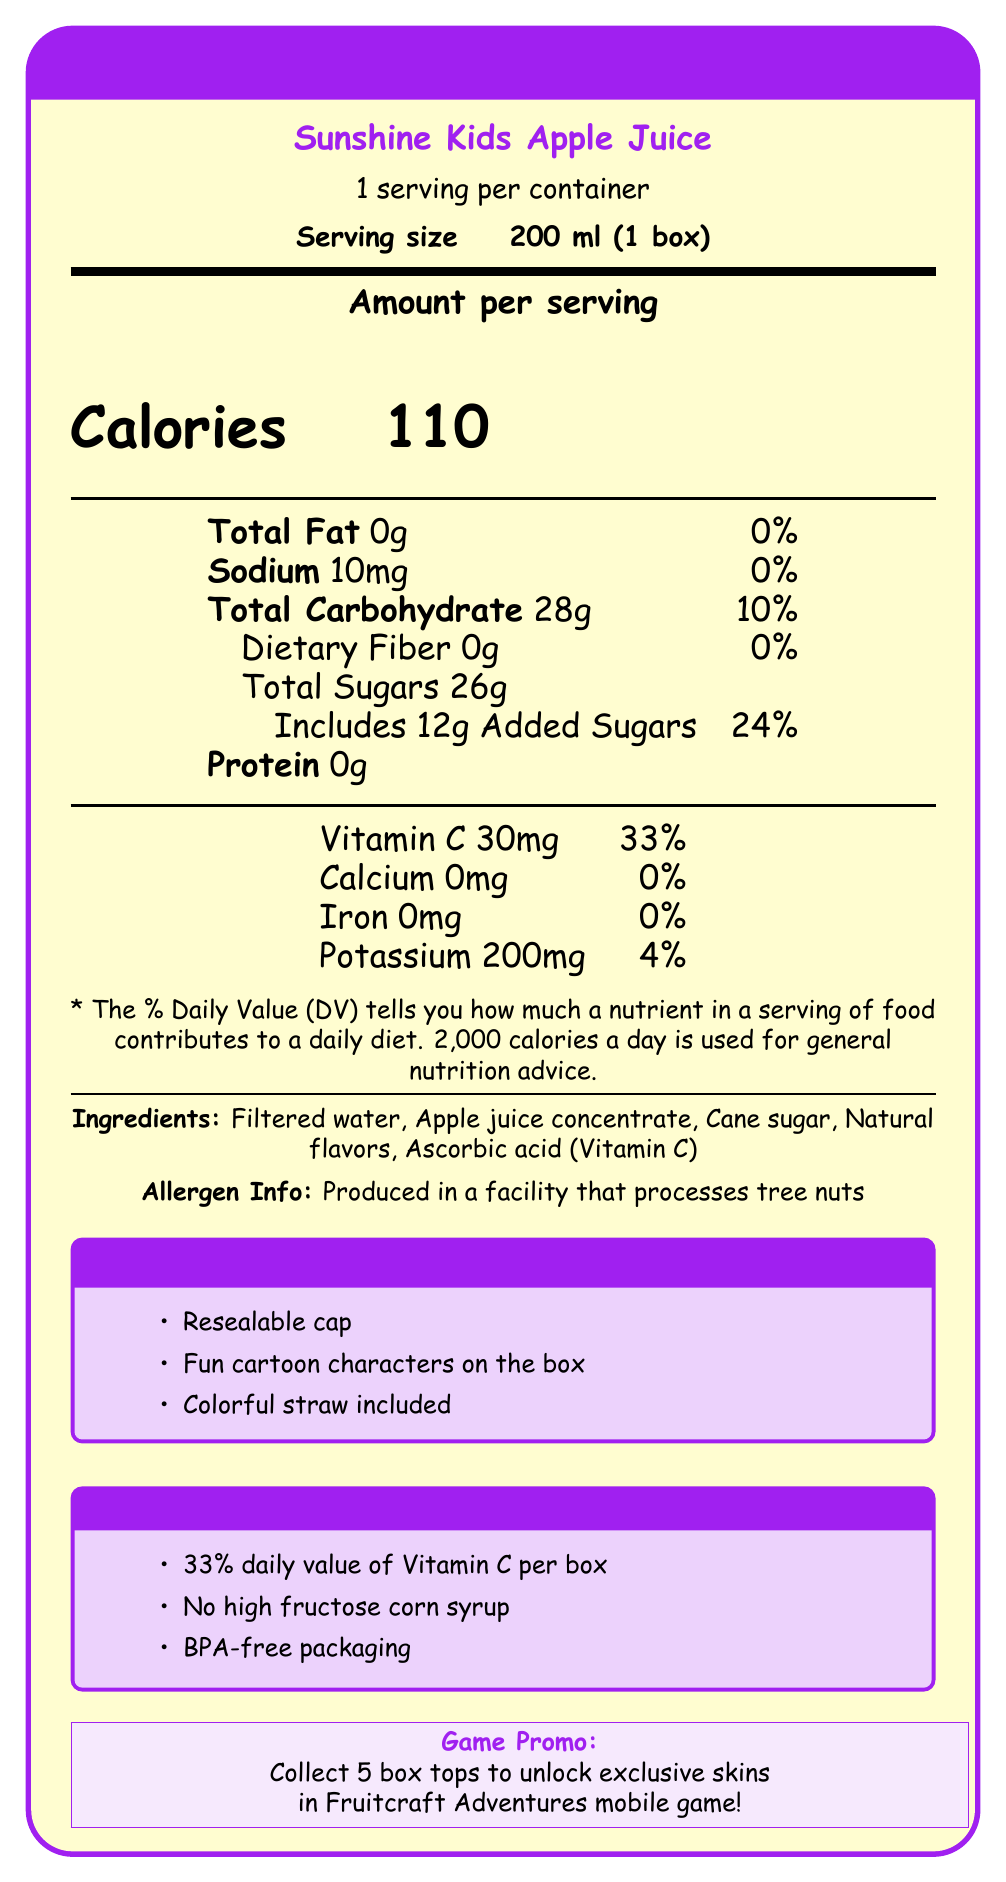How many calories are in one serving of Sunshine Kids Apple Juice? The document states that each serving contains 110 calories.
Answer: 110 calories How many grams of added sugars are in one serving of Sunshine Kids Apple Juice? Under the Total Sugars section, the document specifies that there are 12 grams of added sugars per serving.
Answer: 12 grams What is the daily value percentage of Vitamin C in one serving? The document lists Vitamin C as contributing 33% of the daily value.
Answer: 33% Which ingredient is listed last in the ingredients list? The ingredient list shows that Ascorbic acid (Vitamin C) is the last ingredient mentioned.
Answer: Ascorbic acid (Vitamin C) What is the sodium content per serving? The sodium content listed in the document is 10 mg per serving.
Answer: 10 mg Which of the following is NOT a feature of the Sunshine Kids Apple Juice box?
  A) Resealable cap
  B) Adjustable straw
  C) Fun cartoon characters on the box
  D) 33% daily value of Vitamin C per box The document mentions a "Resealable cap," "Fun cartoon characters on the box," and "33% daily value of Vitamin C per box," but no mention of an "Adjustable straw."
Answer: B) Adjustable straw What is the main purpose of the game-related promotion? 
  1) Promote healthy eating habits
  2) Encourage kids to drink more juice
  3) Unlock exclusive skins in a mobile game
  4) Inform parents about nutrition According to the document, collecting 5 box tops allows you to "unlock exclusive skins in Fruitcraft Adventures mobile game."
Answer: 3) Unlock exclusive skins in a mobile game Does the product contain high fructose corn syrup? The document mentions "No high fructose corn syrup" in the "For Parents" section.
Answer: No Summarize the main points of the Sunshine Kids Apple Juice document. This summary covers the key elements like the nutritional content, kid-friendly features, parent-appealing info, and the game-related promotion.
Answer: Sunshine Kids Apple Juice is a fruit juice product marketed towards children with kid-friendly features such as a resealable cap and colorful straw. It contains 110 calories and 12 grams of added sugars per serving. It provides 33% of the daily value of Vitamin C. The product has no high fructose corn syrup and uses BPA-free packaging. A promotional offer allows collecting box tops to unlock exclusive skins in a mobile game. How many servings are in one container of Sunshine Kids Apple Juice? The document specifies that there is 1 serving per container.
Answer: 1 What does it mean when the label says "Produced in a facility that processes tree nuts"? This statement is included in the allergen information to warn consumers that the product might come in contact with tree nuts.
Answer: It means that the product may contain traces of tree nuts or be exposed to tree nuts during production. Can the document tell us the natural flavors used in Sunshine Kids Apple Juice? The document only states "Natural flavors" without specifying what they are.
Answer: Not enough information What is the potassium content per serving, and what percentage of the daily value does this represent? The document lists potassium content as 200 mg per serving and indicates this is 4% of the daily value.
Answer: 200 mg, 4% 